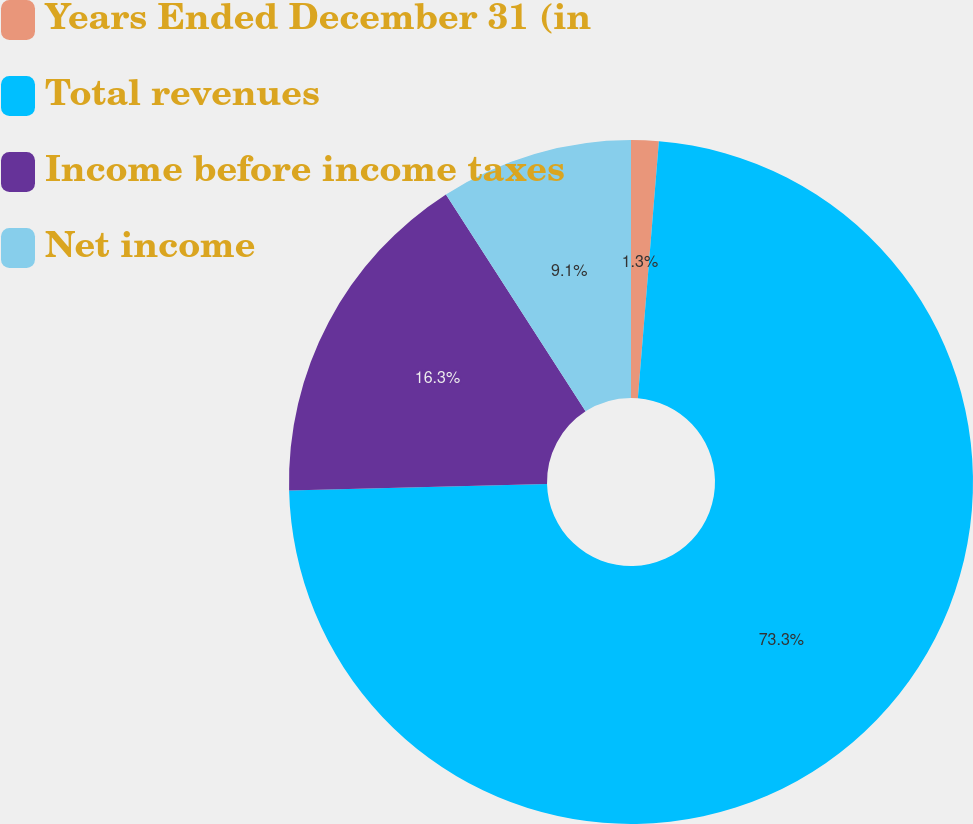Convert chart to OTSL. <chart><loc_0><loc_0><loc_500><loc_500><pie_chart><fcel>Years Ended December 31 (in<fcel>Total revenues<fcel>Income before income taxes<fcel>Net income<nl><fcel>1.3%<fcel>73.31%<fcel>16.3%<fcel>9.1%<nl></chart> 